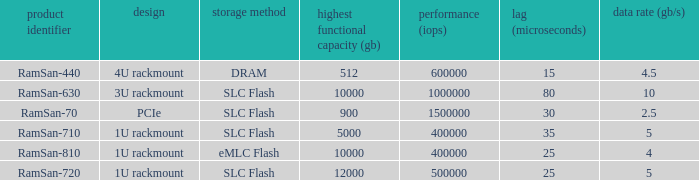How many input/output operations per second does the emlc flash have? 400000.0. 